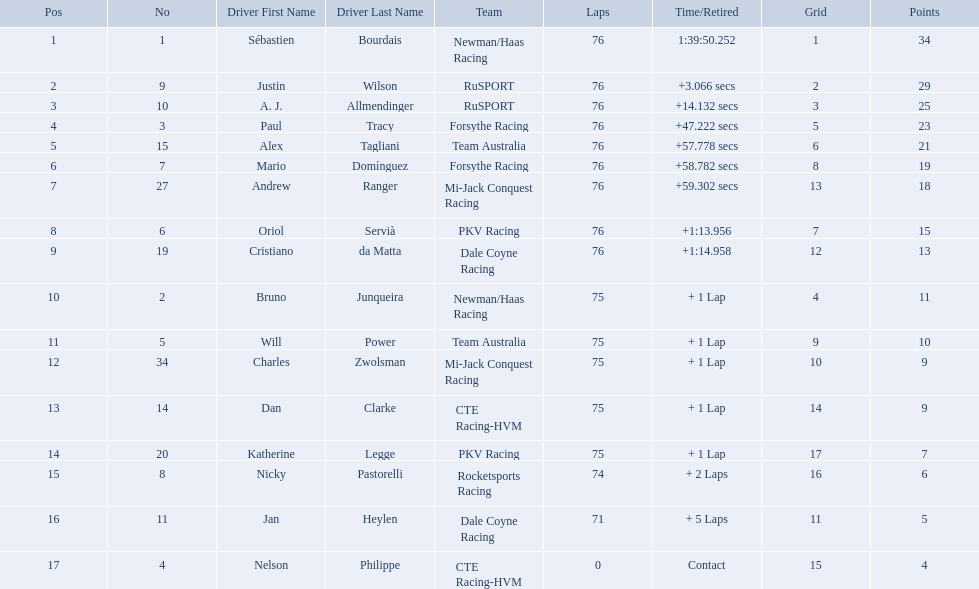Which drivers completed all 76 laps? Sébastien Bourdais, Justin Wilson, A. J. Allmendinger, Paul Tracy, Alex Tagliani, Mario Domínguez, Andrew Ranger, Oriol Servià, Cristiano da Matta. Of these drivers, which ones finished less than a minute behind first place? Paul Tracy, Alex Tagliani, Mario Domínguez, Andrew Ranger. Of these drivers, which ones finished with a time less than 50 seconds behind first place? Justin Wilson, A. J. Allmendinger, Paul Tracy. Of these three drivers, who finished last? Paul Tracy. Who drove during the 2006 tecate grand prix of monterrey? Sébastien Bourdais, Justin Wilson, A. J. Allmendinger, Paul Tracy, Alex Tagliani, Mario Domínguez, Andrew Ranger, Oriol Servià, Cristiano da Matta, Bruno Junqueira, Will Power, Charles Zwolsman, Dan Clarke, Katherine Legge, Nicky Pastorelli, Jan Heylen, Nelson Philippe. And what were their finishing positions? 1, 2, 3, 4, 5, 6, 7, 8, 9, 10, 11, 12, 13, 14, 15, 16, 17. Who did alex tagliani finish directly behind of? Paul Tracy. 